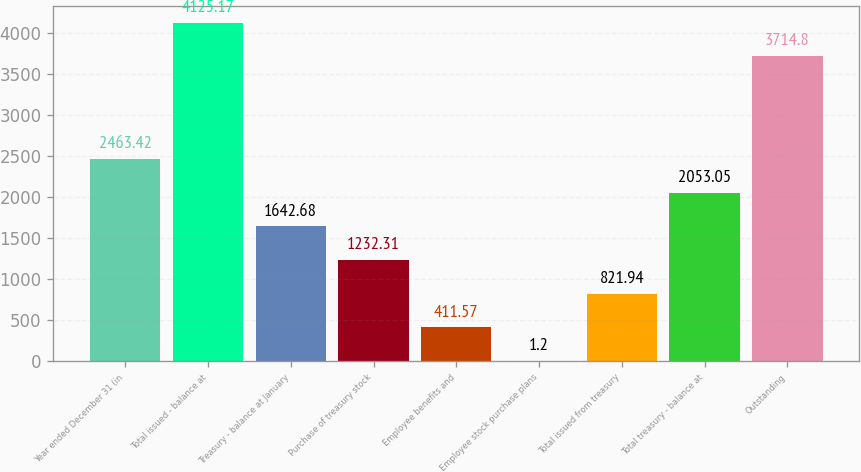Convert chart to OTSL. <chart><loc_0><loc_0><loc_500><loc_500><bar_chart><fcel>Year ended December 31 (in<fcel>Total issued - balance at<fcel>Treasury - balance at January<fcel>Purchase of treasury stock<fcel>Employee benefits and<fcel>Employee stock purchase plans<fcel>Total issued from treasury<fcel>Total treasury - balance at<fcel>Outstanding<nl><fcel>2463.42<fcel>4125.17<fcel>1642.68<fcel>1232.31<fcel>411.57<fcel>1.2<fcel>821.94<fcel>2053.05<fcel>3714.8<nl></chart> 